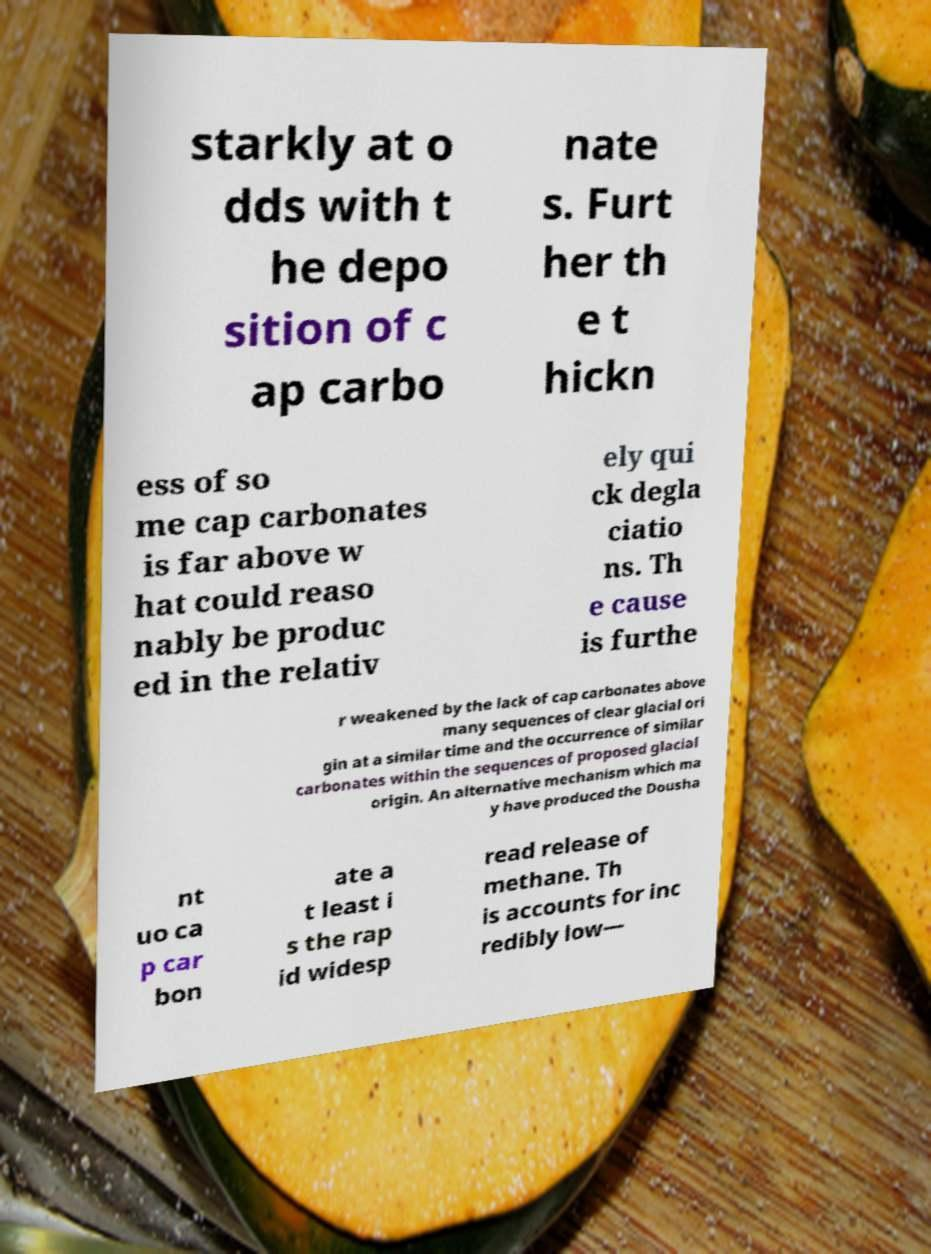There's text embedded in this image that I need extracted. Can you transcribe it verbatim? starkly at o dds with t he depo sition of c ap carbo nate s. Furt her th e t hickn ess of so me cap carbonates is far above w hat could reaso nably be produc ed in the relativ ely qui ck degla ciatio ns. Th e cause is furthe r weakened by the lack of cap carbonates above many sequences of clear glacial ori gin at a similar time and the occurrence of similar carbonates within the sequences of proposed glacial origin. An alternative mechanism which ma y have produced the Dousha nt uo ca p car bon ate a t least i s the rap id widesp read release of methane. Th is accounts for inc redibly low— 